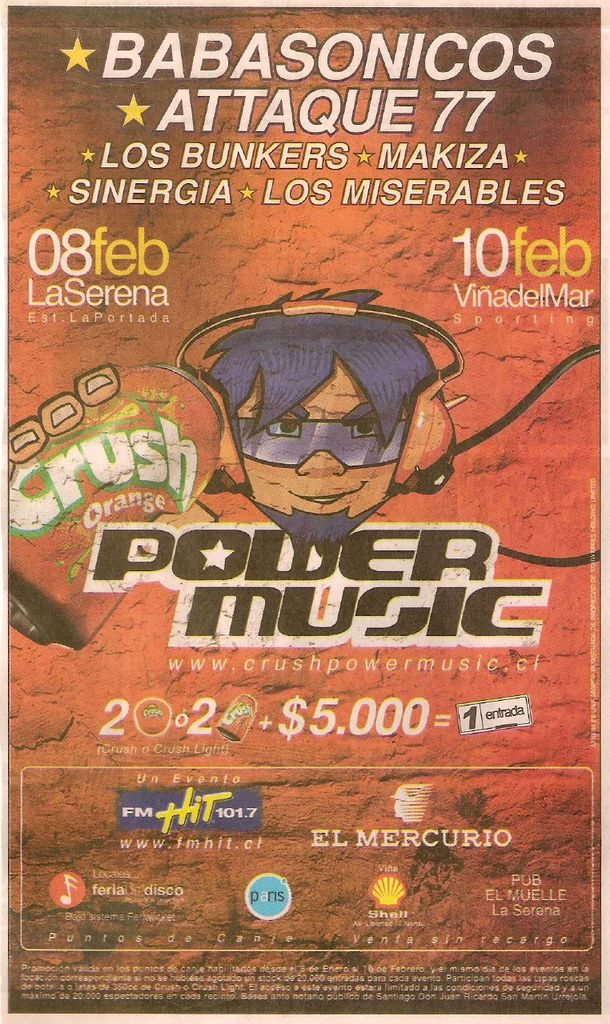What details are provided about ticket pricing and availability? The poster mentions the ticket price of $5,000, and it indicates that tickets can be purchased without additional charges. Are there any sponsors or partners listed for the event? Yes, the event is sponsored by various partners including FM Hit 101.7, El Mercurio, and Crush orange soda, among others. 